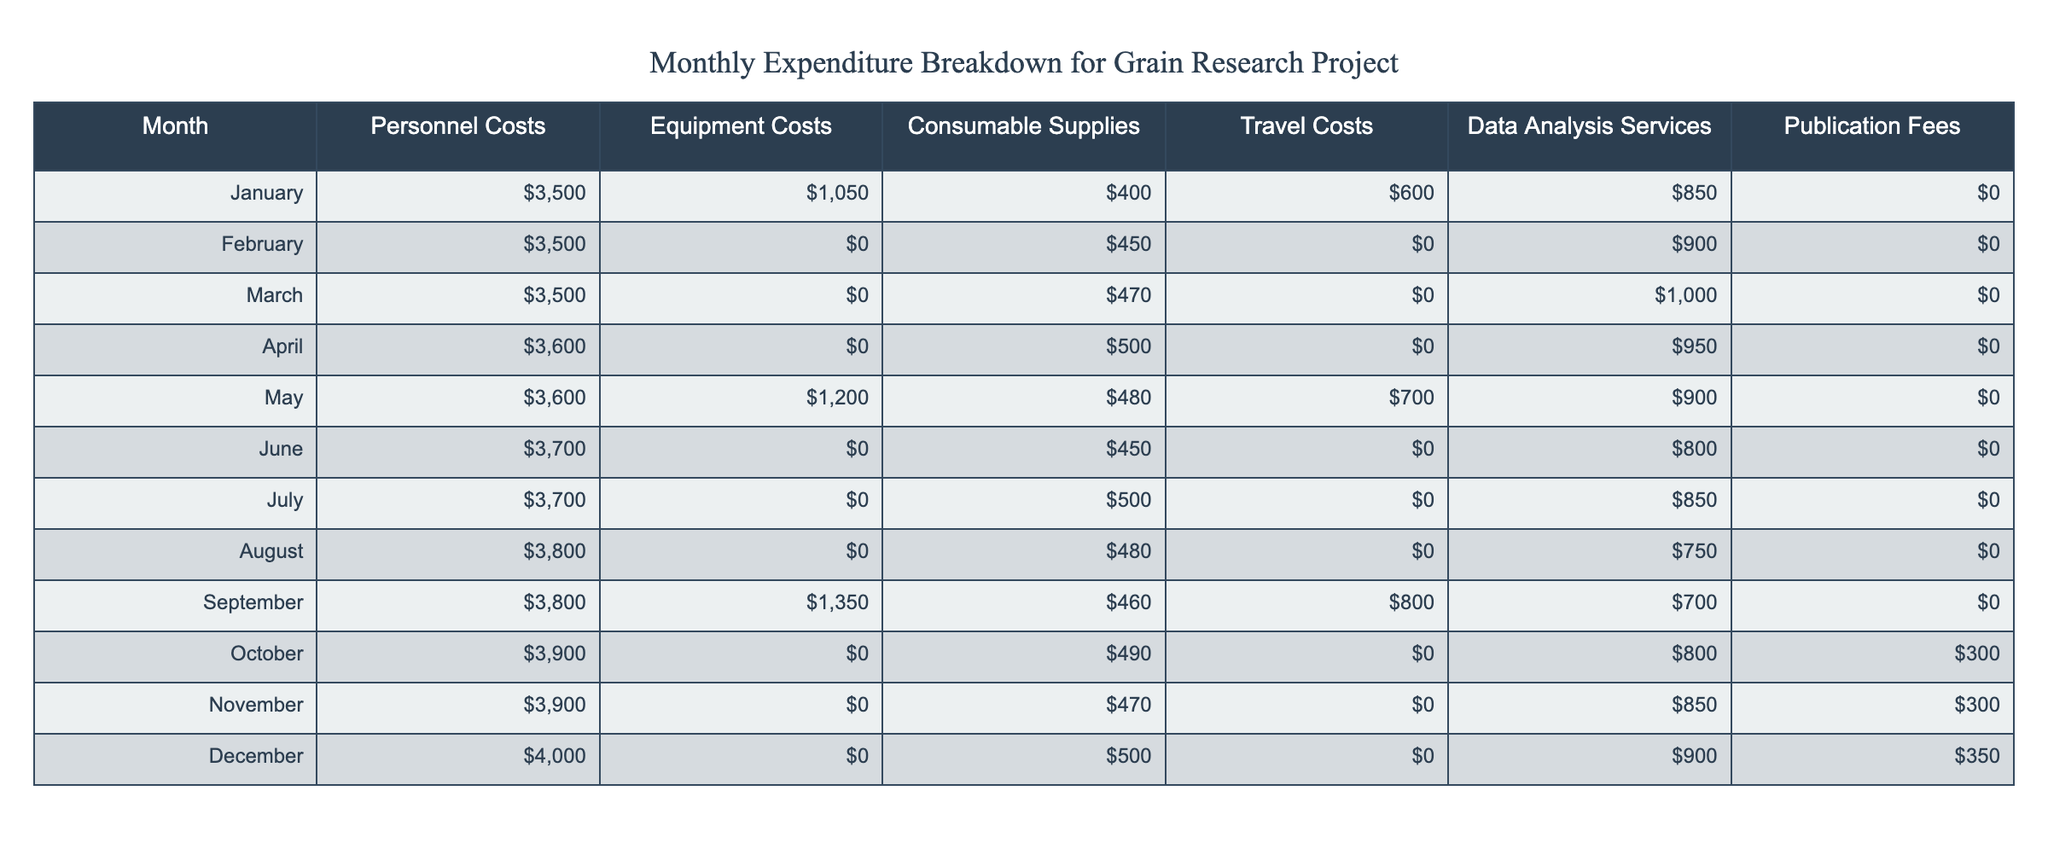What were the total personnel costs from January to March? To find the total personnel costs from January to March, we add the personnel costs for each month: January (3500) + February (3500) + March (3500) = 10500.
Answer: 10500 In which month were equipment costs the highest, and what was the amount? Equipment costs were highest in September, where they amounted to 1350.
Answer: September, 1350 What is the total amount spent on travel costs throughout the year? To find the total travel costs, we sum the travel costs for each month: January (600) + February (0) + March (0) + April (0) + May (700) + June (0) + July (0) + August (0) + September (800) + October (0) + November (0) + December (0) = 2100.
Answer: 2100 Did any month incur publication fees, and if so, which month had the highest fees? Yes, publication fees were incurred in October, November, and December. The highest fees occurred in December, amounting to 350.
Answer: Yes, December, 350 What is the average amount spent on consumable supplies from January to April? First, find the total consumable supplies from January to April: January (400) + February (450) + March (470) + April (500) = 1820. There are 4 months, so the average is 1820 / 4 = 455.
Answer: 455 Were travel costs ever zero in any month, and if yes, how many months had zero travel costs? Yes, travel costs were zero in February, March, April, June, July, August, October, November, and December. This totals to 8 months with zero travel costs.
Answer: Yes, 8 months Which month had the highest combined costs of personal and data analysis services? To identify the month with the highest combined costs, we need to add personnel costs and data analysis services costs for each month. The highest combined value is in December: Personnel (4000) + Data analysis (900) = 4900.
Answer: December, 4900 What are the trends in personnel costs over the months? Personnel costs have shown a gradual increase over the months, starting from 3500 in January, rising to 4000 in December, indicating a consistent upward trend throughout the year.
Answer: Increasing trend 